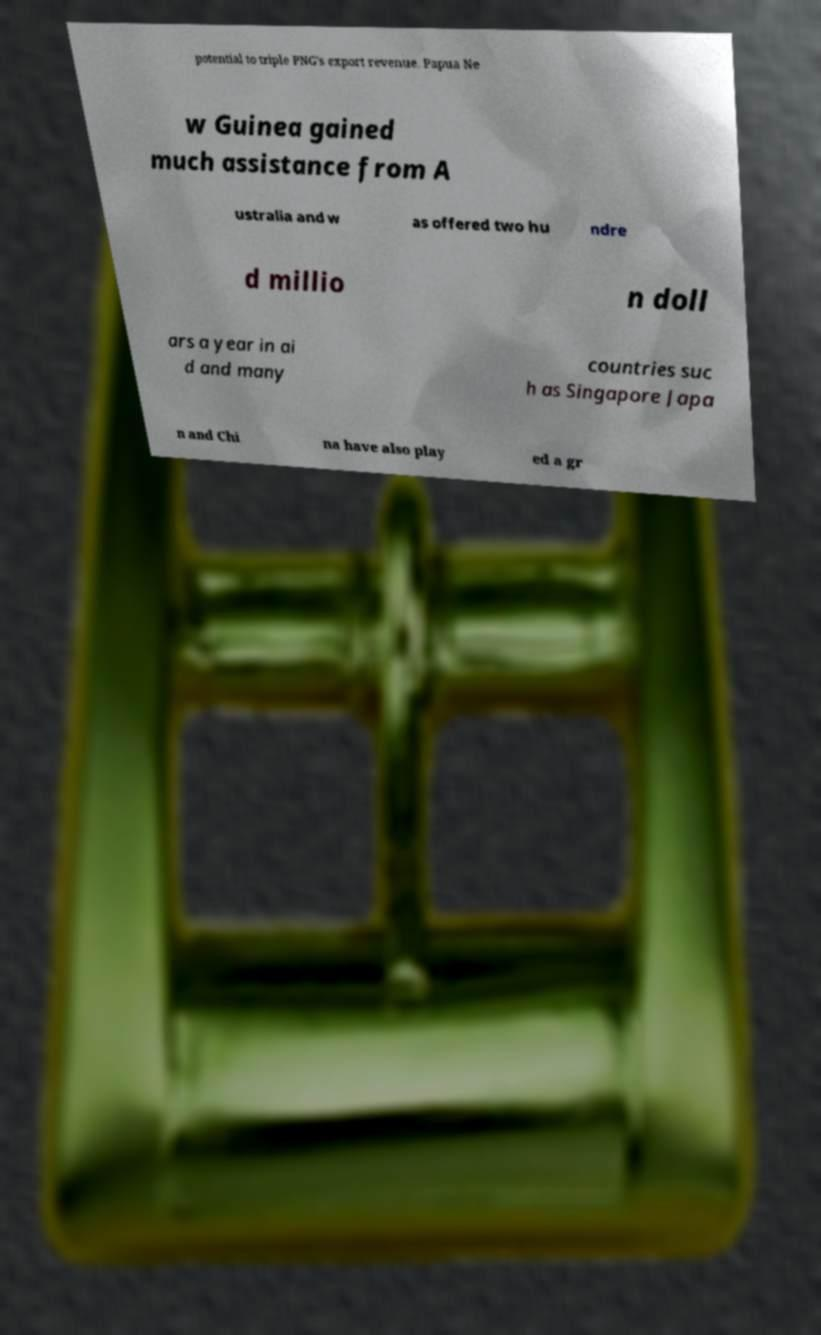Please identify and transcribe the text found in this image. potential to triple PNG's export revenue. Papua Ne w Guinea gained much assistance from A ustralia and w as offered two hu ndre d millio n doll ars a year in ai d and many countries suc h as Singapore Japa n and Chi na have also play ed a gr 